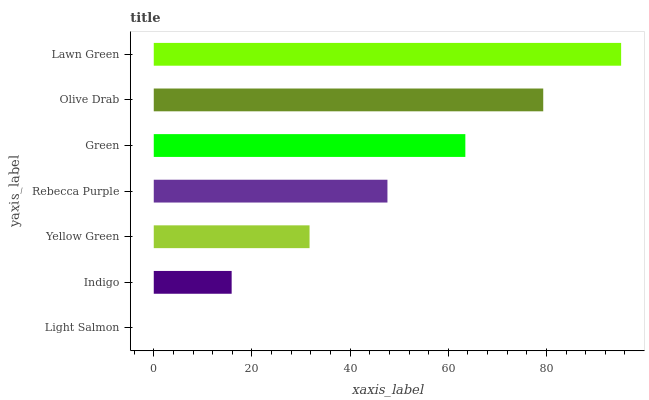Is Light Salmon the minimum?
Answer yes or no. Yes. Is Lawn Green the maximum?
Answer yes or no. Yes. Is Indigo the minimum?
Answer yes or no. No. Is Indigo the maximum?
Answer yes or no. No. Is Indigo greater than Light Salmon?
Answer yes or no. Yes. Is Light Salmon less than Indigo?
Answer yes or no. Yes. Is Light Salmon greater than Indigo?
Answer yes or no. No. Is Indigo less than Light Salmon?
Answer yes or no. No. Is Rebecca Purple the high median?
Answer yes or no. Yes. Is Rebecca Purple the low median?
Answer yes or no. Yes. Is Lawn Green the high median?
Answer yes or no. No. Is Light Salmon the low median?
Answer yes or no. No. 